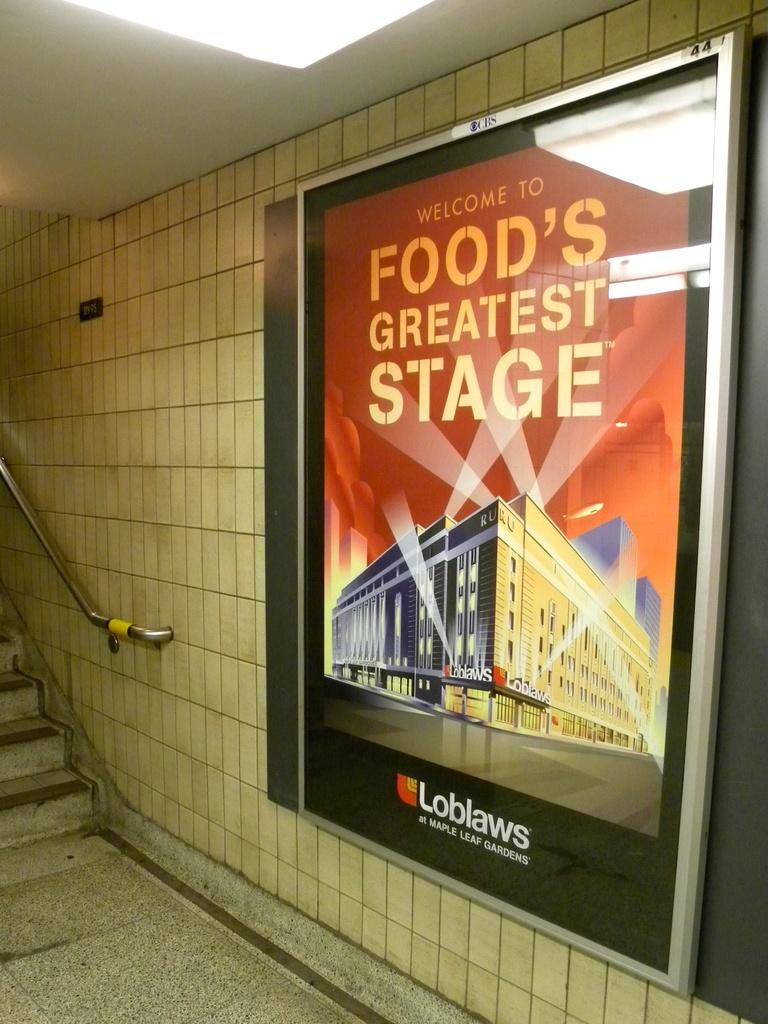Provide a one-sentence caption for the provided image. A sign by the stairs that says welcome to food's greatest stage. 